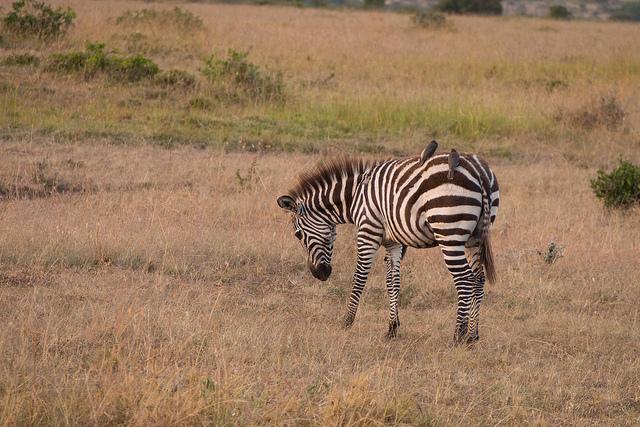Is the zebra alone?
Write a very short answer. Yes. How many zebra are in the picture?
Give a very brief answer. 1. Is the animal looking at the camera?
Give a very brief answer. No. How many zebras are there?
Quick response, please. 1. How many zebras are in this picture?
Quick response, please. 1. Is the zebra facing left or right?
Concise answer only. Left. How many types of animals are there?
Give a very brief answer. 1. Can you see any trees in the picture?
Answer briefly. No. How many animals are depicted?
Answer briefly. 1. What are sitting on the zebra?
Write a very short answer. Birds. How many birds on zebra?
Short answer required. 2. How many animals can be seen?
Be succinct. 1. Is there a rock in the picture?
Concise answer only. No. Is the animal's tail straight down?
Give a very brief answer. Yes. Is this animal aroused?
Short answer required. No. 